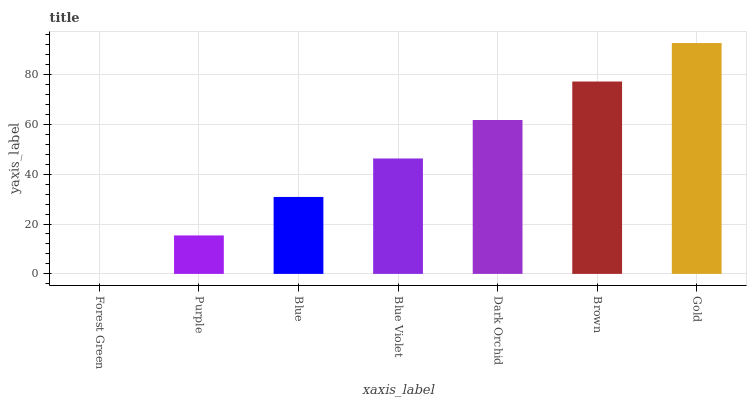Is Forest Green the minimum?
Answer yes or no. Yes. Is Gold the maximum?
Answer yes or no. Yes. Is Purple the minimum?
Answer yes or no. No. Is Purple the maximum?
Answer yes or no. No. Is Purple greater than Forest Green?
Answer yes or no. Yes. Is Forest Green less than Purple?
Answer yes or no. Yes. Is Forest Green greater than Purple?
Answer yes or no. No. Is Purple less than Forest Green?
Answer yes or no. No. Is Blue Violet the high median?
Answer yes or no. Yes. Is Blue Violet the low median?
Answer yes or no. Yes. Is Blue the high median?
Answer yes or no. No. Is Brown the low median?
Answer yes or no. No. 